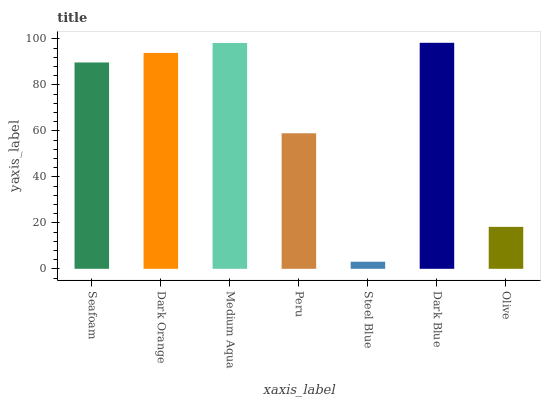Is Steel Blue the minimum?
Answer yes or no. Yes. Is Dark Blue the maximum?
Answer yes or no. Yes. Is Dark Orange the minimum?
Answer yes or no. No. Is Dark Orange the maximum?
Answer yes or no. No. Is Dark Orange greater than Seafoam?
Answer yes or no. Yes. Is Seafoam less than Dark Orange?
Answer yes or no. Yes. Is Seafoam greater than Dark Orange?
Answer yes or no. No. Is Dark Orange less than Seafoam?
Answer yes or no. No. Is Seafoam the high median?
Answer yes or no. Yes. Is Seafoam the low median?
Answer yes or no. Yes. Is Dark Orange the high median?
Answer yes or no. No. Is Dark Blue the low median?
Answer yes or no. No. 